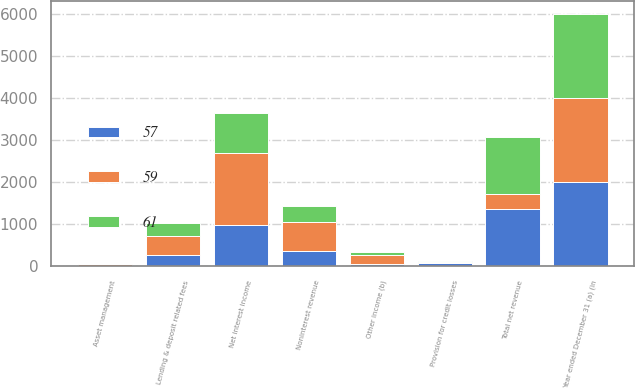Convert chart to OTSL. <chart><loc_0><loc_0><loc_500><loc_500><stacked_bar_chart><ecel><fcel>Year ended December 31 (a) (in<fcel>Lending & deposit related fees<fcel>Asset management<fcel>Other income (b)<fcel>Noninterest revenue<fcel>Net interest income<fcel>Total net revenue<fcel>Provision for credit losses<nl><fcel>59<fcel>2004<fcel>441<fcel>32<fcel>209<fcel>682<fcel>1692<fcel>366<fcel>41<nl><fcel>61<fcel>2003<fcel>301<fcel>19<fcel>73<fcel>393<fcel>959<fcel>1352<fcel>6<nl><fcel>57<fcel>2002<fcel>285<fcel>16<fcel>65<fcel>366<fcel>999<fcel>1365<fcel>72<nl></chart> 